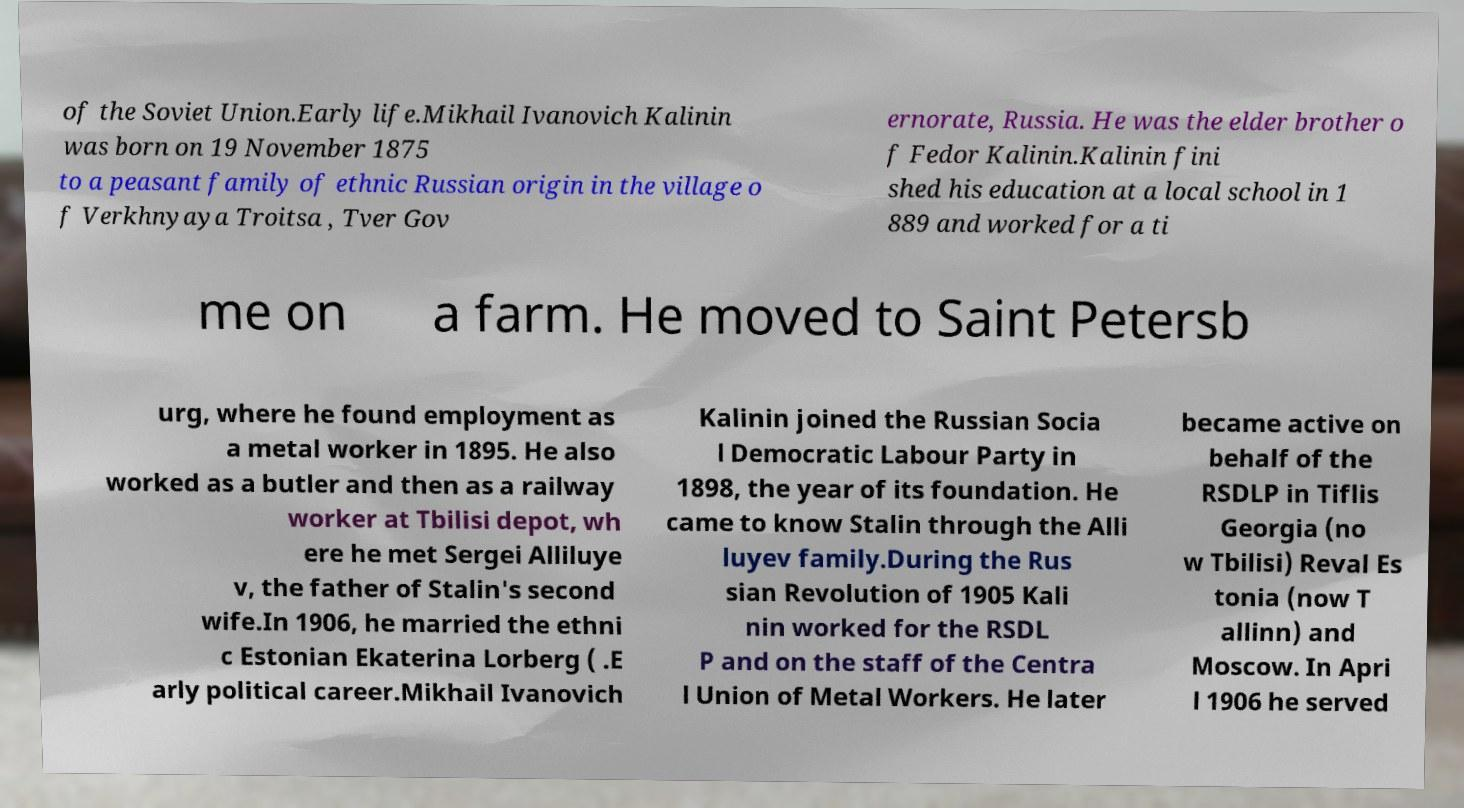There's text embedded in this image that I need extracted. Can you transcribe it verbatim? of the Soviet Union.Early life.Mikhail Ivanovich Kalinin was born on 19 November 1875 to a peasant family of ethnic Russian origin in the village o f Verkhnyaya Troitsa , Tver Gov ernorate, Russia. He was the elder brother o f Fedor Kalinin.Kalinin fini shed his education at a local school in 1 889 and worked for a ti me on a farm. He moved to Saint Petersb urg, where he found employment as a metal worker in 1895. He also worked as a butler and then as a railway worker at Tbilisi depot, wh ere he met Sergei Alliluye v, the father of Stalin's second wife.In 1906, he married the ethni c Estonian Ekaterina Lorberg ( .E arly political career.Mikhail Ivanovich Kalinin joined the Russian Socia l Democratic Labour Party in 1898, the year of its foundation. He came to know Stalin through the Alli luyev family.During the Rus sian Revolution of 1905 Kali nin worked for the RSDL P and on the staff of the Centra l Union of Metal Workers. He later became active on behalf of the RSDLP in Tiflis Georgia (no w Tbilisi) Reval Es tonia (now T allinn) and Moscow. In Apri l 1906 he served 